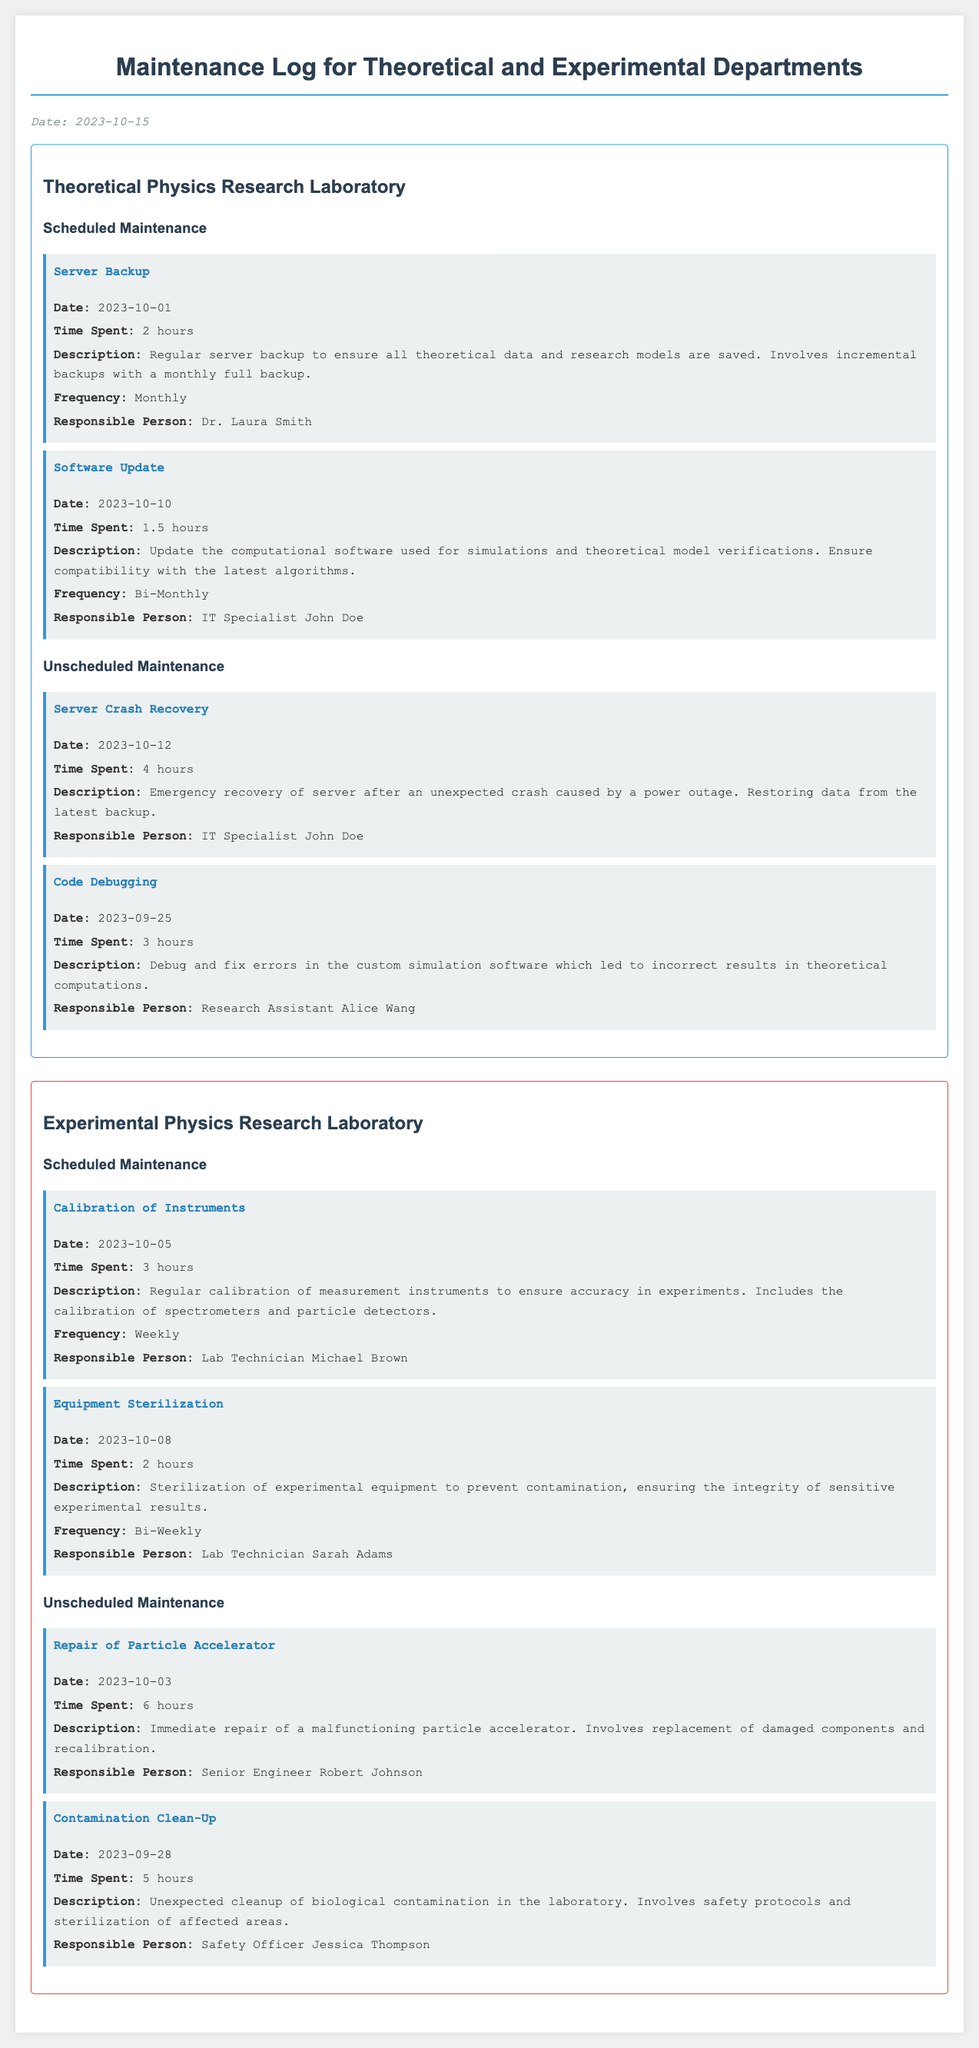what is the date of the server crash recovery? The date of the server crash recovery is explicitly listed in the unscheduled maintenance activities for the theoretical department.
Answer: 2023-10-12 how many hours were spent on the equipment sterilization? The time spent on the equipment sterilization activity is mentioned in the scheduled maintenance section of the experimental department.
Answer: 2 hours who was responsible for the calibration of instruments? The responsible person for the calibration of instruments is clearly noted in the scheduled maintenance section of the experimental department.
Answer: Lab Technician Michael Brown what was the reason for the unscheduled maintenance regarding code debugging? This reason is stated in the details of the unscheduled maintenance activities in the theoretical department.
Answer: Debug and fix errors in the custom simulation software which department conducted the server backup activity? The specific department that conducted the server backup activity can be found in the scheduled maintenance section under a title.
Answer: Theoretical Physics Research Laboratory how many unscheduled maintenance activities occurred in the theoretical department? The document specifies the number of unscheduled maintenance activities listed under the theoretical department.
Answer: 2 activities what type of maintenance was the particle accelerator repair classified as? This classification is indicated in the unscheduled maintenance activities section of the experimental department.
Answer: Unscheduled Maintenance when was the last scheduled maintenance for software updates? The date for the last scheduled maintenance is detailed in the scheduled maintenance activities for the theoretical department.
Answer: 2023-10-10 